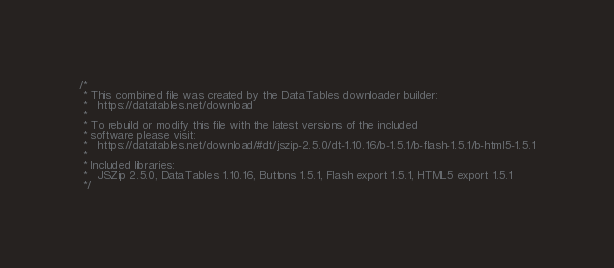Convert code to text. <code><loc_0><loc_0><loc_500><loc_500><_CSS_>/*
 * This combined file was created by the DataTables downloader builder:
 *   https://datatables.net/download
 *
 * To rebuild or modify this file with the latest versions of the included
 * software please visit:
 *   https://datatables.net/download/#dt/jszip-2.5.0/dt-1.10.16/b-1.5.1/b-flash-1.5.1/b-html5-1.5.1
 *
 * Included libraries:
 *   JSZip 2.5.0, DataTables 1.10.16, Buttons 1.5.1, Flash export 1.5.1, HTML5 export 1.5.1
 */
</code> 